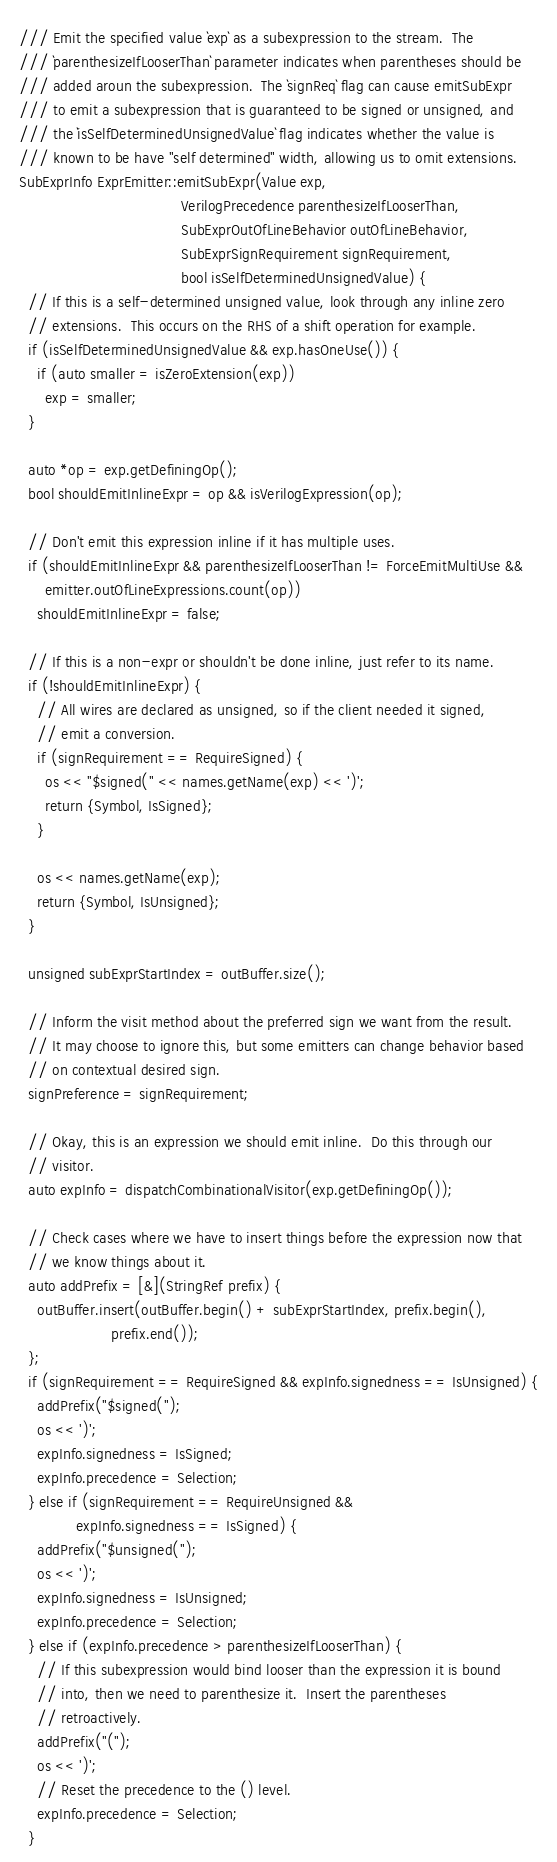Convert code to text. <code><loc_0><loc_0><loc_500><loc_500><_C++_>
/// Emit the specified value `exp` as a subexpression to the stream.  The
/// `parenthesizeIfLooserThan` parameter indicates when parentheses should be
/// added aroun the subexpression.  The `signReq` flag can cause emitSubExpr
/// to emit a subexpression that is guaranteed to be signed or unsigned, and
/// the `isSelfDeterminedUnsignedValue` flag indicates whether the value is
/// known to be have "self determined" width, allowing us to omit extensions.
SubExprInfo ExprEmitter::emitSubExpr(Value exp,
                                     VerilogPrecedence parenthesizeIfLooserThan,
                                     SubExprOutOfLineBehavior outOfLineBehavior,
                                     SubExprSignRequirement signRequirement,
                                     bool isSelfDeterminedUnsignedValue) {
  // If this is a self-determined unsigned value, look through any inline zero
  // extensions.  This occurs on the RHS of a shift operation for example.
  if (isSelfDeterminedUnsignedValue && exp.hasOneUse()) {
    if (auto smaller = isZeroExtension(exp))
      exp = smaller;
  }

  auto *op = exp.getDefiningOp();
  bool shouldEmitInlineExpr = op && isVerilogExpression(op);

  // Don't emit this expression inline if it has multiple uses.
  if (shouldEmitInlineExpr && parenthesizeIfLooserThan != ForceEmitMultiUse &&
      emitter.outOfLineExpressions.count(op))
    shouldEmitInlineExpr = false;

  // If this is a non-expr or shouldn't be done inline, just refer to its name.
  if (!shouldEmitInlineExpr) {
    // All wires are declared as unsigned, so if the client needed it signed,
    // emit a conversion.
    if (signRequirement == RequireSigned) {
      os << "$signed(" << names.getName(exp) << ')';
      return {Symbol, IsSigned};
    }

    os << names.getName(exp);
    return {Symbol, IsUnsigned};
  }

  unsigned subExprStartIndex = outBuffer.size();

  // Inform the visit method about the preferred sign we want from the result.
  // It may choose to ignore this, but some emitters can change behavior based
  // on contextual desired sign.
  signPreference = signRequirement;

  // Okay, this is an expression we should emit inline.  Do this through our
  // visitor.
  auto expInfo = dispatchCombinationalVisitor(exp.getDefiningOp());

  // Check cases where we have to insert things before the expression now that
  // we know things about it.
  auto addPrefix = [&](StringRef prefix) {
    outBuffer.insert(outBuffer.begin() + subExprStartIndex, prefix.begin(),
                     prefix.end());
  };
  if (signRequirement == RequireSigned && expInfo.signedness == IsUnsigned) {
    addPrefix("$signed(");
    os << ')';
    expInfo.signedness = IsSigned;
    expInfo.precedence = Selection;
  } else if (signRequirement == RequireUnsigned &&
             expInfo.signedness == IsSigned) {
    addPrefix("$unsigned(");
    os << ')';
    expInfo.signedness = IsUnsigned;
    expInfo.precedence = Selection;
  } else if (expInfo.precedence > parenthesizeIfLooserThan) {
    // If this subexpression would bind looser than the expression it is bound
    // into, then we need to parenthesize it.  Insert the parentheses
    // retroactively.
    addPrefix("(");
    os << ')';
    // Reset the precedence to the () level.
    expInfo.precedence = Selection;
  }
</code> 